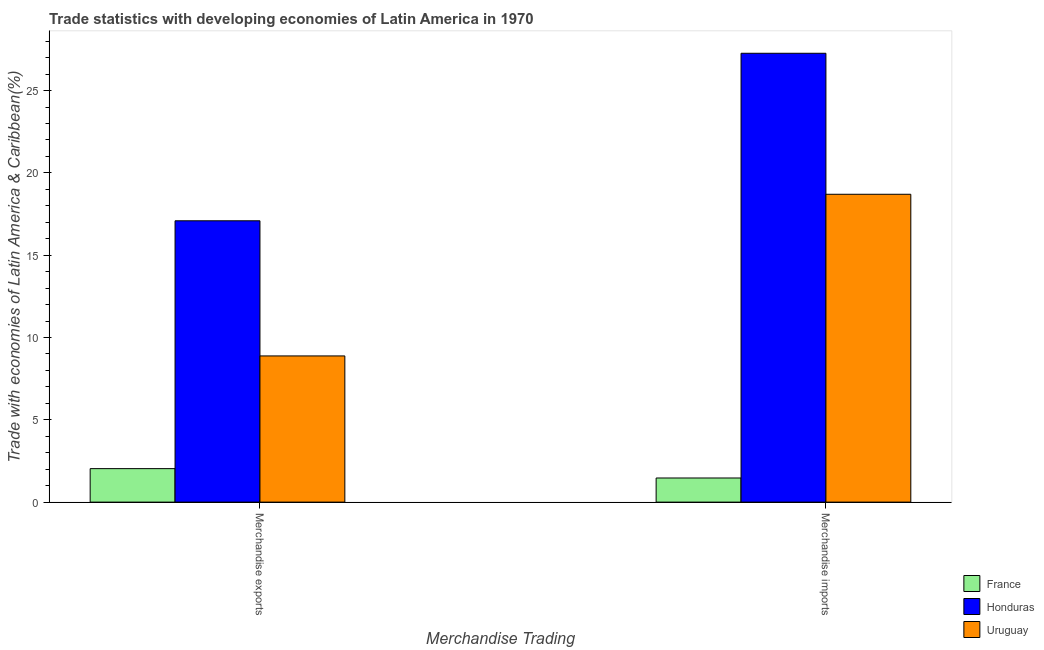How many different coloured bars are there?
Provide a short and direct response. 3. How many groups of bars are there?
Provide a short and direct response. 2. Are the number of bars per tick equal to the number of legend labels?
Provide a short and direct response. Yes. How many bars are there on the 1st tick from the left?
Offer a very short reply. 3. What is the merchandise exports in Uruguay?
Keep it short and to the point. 8.88. Across all countries, what is the maximum merchandise imports?
Your response must be concise. 27.27. Across all countries, what is the minimum merchandise exports?
Your answer should be compact. 2.03. In which country was the merchandise imports maximum?
Give a very brief answer. Honduras. What is the total merchandise exports in the graph?
Give a very brief answer. 28. What is the difference between the merchandise imports in Honduras and that in France?
Your answer should be compact. 25.8. What is the difference between the merchandise imports in France and the merchandise exports in Honduras?
Give a very brief answer. -15.62. What is the average merchandise imports per country?
Offer a very short reply. 15.81. What is the difference between the merchandise imports and merchandise exports in Uruguay?
Provide a succinct answer. 9.82. In how many countries, is the merchandise imports greater than 5 %?
Offer a very short reply. 2. What is the ratio of the merchandise exports in France to that in Uruguay?
Your response must be concise. 0.23. Is the merchandise exports in Uruguay less than that in Honduras?
Ensure brevity in your answer.  Yes. In how many countries, is the merchandise imports greater than the average merchandise imports taken over all countries?
Offer a terse response. 2. What does the 3rd bar from the left in Merchandise exports represents?
Your response must be concise. Uruguay. What does the 2nd bar from the right in Merchandise imports represents?
Give a very brief answer. Honduras. How many bars are there?
Keep it short and to the point. 6. Are all the bars in the graph horizontal?
Your response must be concise. No. How many countries are there in the graph?
Offer a terse response. 3. Are the values on the major ticks of Y-axis written in scientific E-notation?
Ensure brevity in your answer.  No. Where does the legend appear in the graph?
Provide a short and direct response. Bottom right. How are the legend labels stacked?
Make the answer very short. Vertical. What is the title of the graph?
Your answer should be very brief. Trade statistics with developing economies of Latin America in 1970. Does "Mongolia" appear as one of the legend labels in the graph?
Ensure brevity in your answer.  No. What is the label or title of the X-axis?
Your answer should be compact. Merchandise Trading. What is the label or title of the Y-axis?
Offer a very short reply. Trade with economies of Latin America & Caribbean(%). What is the Trade with economies of Latin America & Caribbean(%) of France in Merchandise exports?
Your answer should be very brief. 2.03. What is the Trade with economies of Latin America & Caribbean(%) in Honduras in Merchandise exports?
Offer a very short reply. 17.09. What is the Trade with economies of Latin America & Caribbean(%) in Uruguay in Merchandise exports?
Ensure brevity in your answer.  8.88. What is the Trade with economies of Latin America & Caribbean(%) in France in Merchandise imports?
Offer a very short reply. 1.47. What is the Trade with economies of Latin America & Caribbean(%) of Honduras in Merchandise imports?
Provide a short and direct response. 27.27. What is the Trade with economies of Latin America & Caribbean(%) in Uruguay in Merchandise imports?
Keep it short and to the point. 18.7. Across all Merchandise Trading, what is the maximum Trade with economies of Latin America & Caribbean(%) in France?
Offer a terse response. 2.03. Across all Merchandise Trading, what is the maximum Trade with economies of Latin America & Caribbean(%) in Honduras?
Provide a succinct answer. 27.27. Across all Merchandise Trading, what is the maximum Trade with economies of Latin America & Caribbean(%) of Uruguay?
Your answer should be compact. 18.7. Across all Merchandise Trading, what is the minimum Trade with economies of Latin America & Caribbean(%) of France?
Keep it short and to the point. 1.47. Across all Merchandise Trading, what is the minimum Trade with economies of Latin America & Caribbean(%) in Honduras?
Provide a succinct answer. 17.09. Across all Merchandise Trading, what is the minimum Trade with economies of Latin America & Caribbean(%) in Uruguay?
Ensure brevity in your answer.  8.88. What is the total Trade with economies of Latin America & Caribbean(%) in France in the graph?
Your response must be concise. 3.5. What is the total Trade with economies of Latin America & Caribbean(%) in Honduras in the graph?
Your answer should be compact. 44.36. What is the total Trade with economies of Latin America & Caribbean(%) of Uruguay in the graph?
Provide a succinct answer. 27.58. What is the difference between the Trade with economies of Latin America & Caribbean(%) in France in Merchandise exports and that in Merchandise imports?
Provide a succinct answer. 0.57. What is the difference between the Trade with economies of Latin America & Caribbean(%) of Honduras in Merchandise exports and that in Merchandise imports?
Your answer should be very brief. -10.18. What is the difference between the Trade with economies of Latin America & Caribbean(%) in Uruguay in Merchandise exports and that in Merchandise imports?
Ensure brevity in your answer.  -9.82. What is the difference between the Trade with economies of Latin America & Caribbean(%) in France in Merchandise exports and the Trade with economies of Latin America & Caribbean(%) in Honduras in Merchandise imports?
Offer a terse response. -25.23. What is the difference between the Trade with economies of Latin America & Caribbean(%) in France in Merchandise exports and the Trade with economies of Latin America & Caribbean(%) in Uruguay in Merchandise imports?
Offer a very short reply. -16.67. What is the difference between the Trade with economies of Latin America & Caribbean(%) of Honduras in Merchandise exports and the Trade with economies of Latin America & Caribbean(%) of Uruguay in Merchandise imports?
Keep it short and to the point. -1.61. What is the average Trade with economies of Latin America & Caribbean(%) in France per Merchandise Trading?
Your response must be concise. 1.75. What is the average Trade with economies of Latin America & Caribbean(%) of Honduras per Merchandise Trading?
Offer a terse response. 22.18. What is the average Trade with economies of Latin America & Caribbean(%) in Uruguay per Merchandise Trading?
Your answer should be very brief. 13.79. What is the difference between the Trade with economies of Latin America & Caribbean(%) in France and Trade with economies of Latin America & Caribbean(%) in Honduras in Merchandise exports?
Keep it short and to the point. -15.06. What is the difference between the Trade with economies of Latin America & Caribbean(%) of France and Trade with economies of Latin America & Caribbean(%) of Uruguay in Merchandise exports?
Your answer should be very brief. -6.85. What is the difference between the Trade with economies of Latin America & Caribbean(%) of Honduras and Trade with economies of Latin America & Caribbean(%) of Uruguay in Merchandise exports?
Provide a short and direct response. 8.21. What is the difference between the Trade with economies of Latin America & Caribbean(%) in France and Trade with economies of Latin America & Caribbean(%) in Honduras in Merchandise imports?
Your response must be concise. -25.8. What is the difference between the Trade with economies of Latin America & Caribbean(%) in France and Trade with economies of Latin America & Caribbean(%) in Uruguay in Merchandise imports?
Your response must be concise. -17.24. What is the difference between the Trade with economies of Latin America & Caribbean(%) in Honduras and Trade with economies of Latin America & Caribbean(%) in Uruguay in Merchandise imports?
Offer a terse response. 8.57. What is the ratio of the Trade with economies of Latin America & Caribbean(%) of France in Merchandise exports to that in Merchandise imports?
Make the answer very short. 1.39. What is the ratio of the Trade with economies of Latin America & Caribbean(%) of Honduras in Merchandise exports to that in Merchandise imports?
Provide a succinct answer. 0.63. What is the ratio of the Trade with economies of Latin America & Caribbean(%) of Uruguay in Merchandise exports to that in Merchandise imports?
Your answer should be very brief. 0.47. What is the difference between the highest and the second highest Trade with economies of Latin America & Caribbean(%) of France?
Your answer should be very brief. 0.57. What is the difference between the highest and the second highest Trade with economies of Latin America & Caribbean(%) of Honduras?
Offer a very short reply. 10.18. What is the difference between the highest and the second highest Trade with economies of Latin America & Caribbean(%) of Uruguay?
Your answer should be very brief. 9.82. What is the difference between the highest and the lowest Trade with economies of Latin America & Caribbean(%) in France?
Your response must be concise. 0.57. What is the difference between the highest and the lowest Trade with economies of Latin America & Caribbean(%) in Honduras?
Provide a short and direct response. 10.18. What is the difference between the highest and the lowest Trade with economies of Latin America & Caribbean(%) of Uruguay?
Keep it short and to the point. 9.82. 